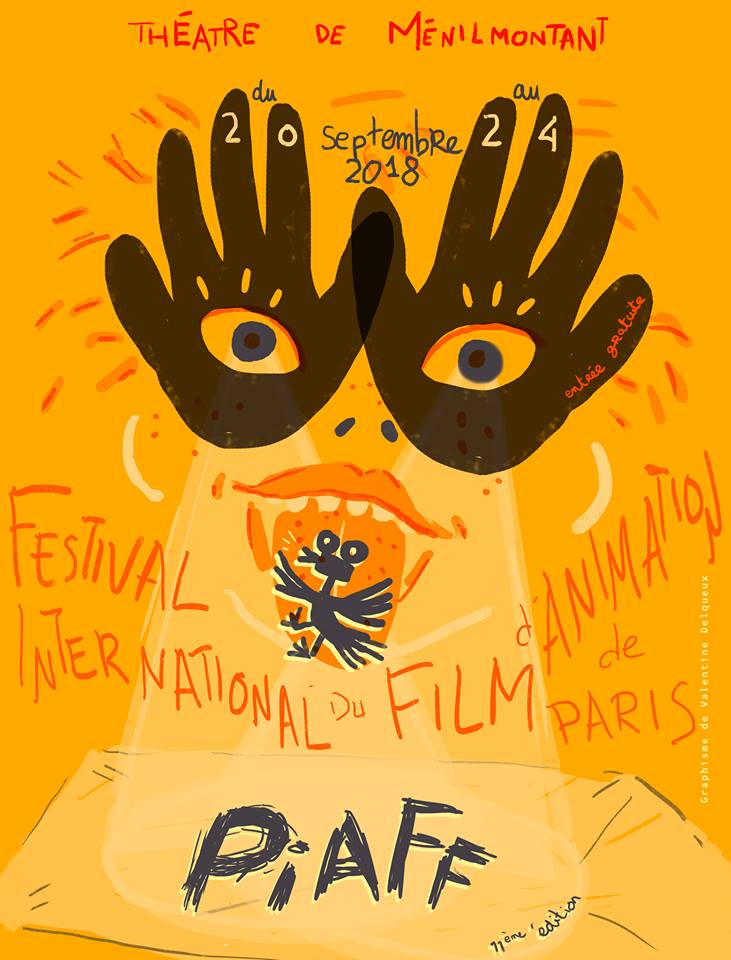What does the use of the word "P·A·F" in large letters at the bottom of the poster indicate about the branding or identity of the event? The use of the acronym "P·A·F" in large, bold letters at the bottom of the poster emphasizes its role as a key branding element for the 'Paris International Animation Film Festival'. This design choice ensures that the event's identity is instantly recognizable and memorable to the audience. The bold typography not only underscores the importance of the festival but also creates a strong visual impact, aligning with the artistic and creative nature of the animation industry. Additionally, this prominent placement helps in establishing the acronym as potentially iconic, fostering an immediate association with the festival's brand and identity in the public's perception. 